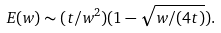Convert formula to latex. <formula><loc_0><loc_0><loc_500><loc_500>E ( w ) \sim ( t / w ^ { 2 } ) ( 1 - \sqrt { w / ( 4 t ) } ) .</formula> 